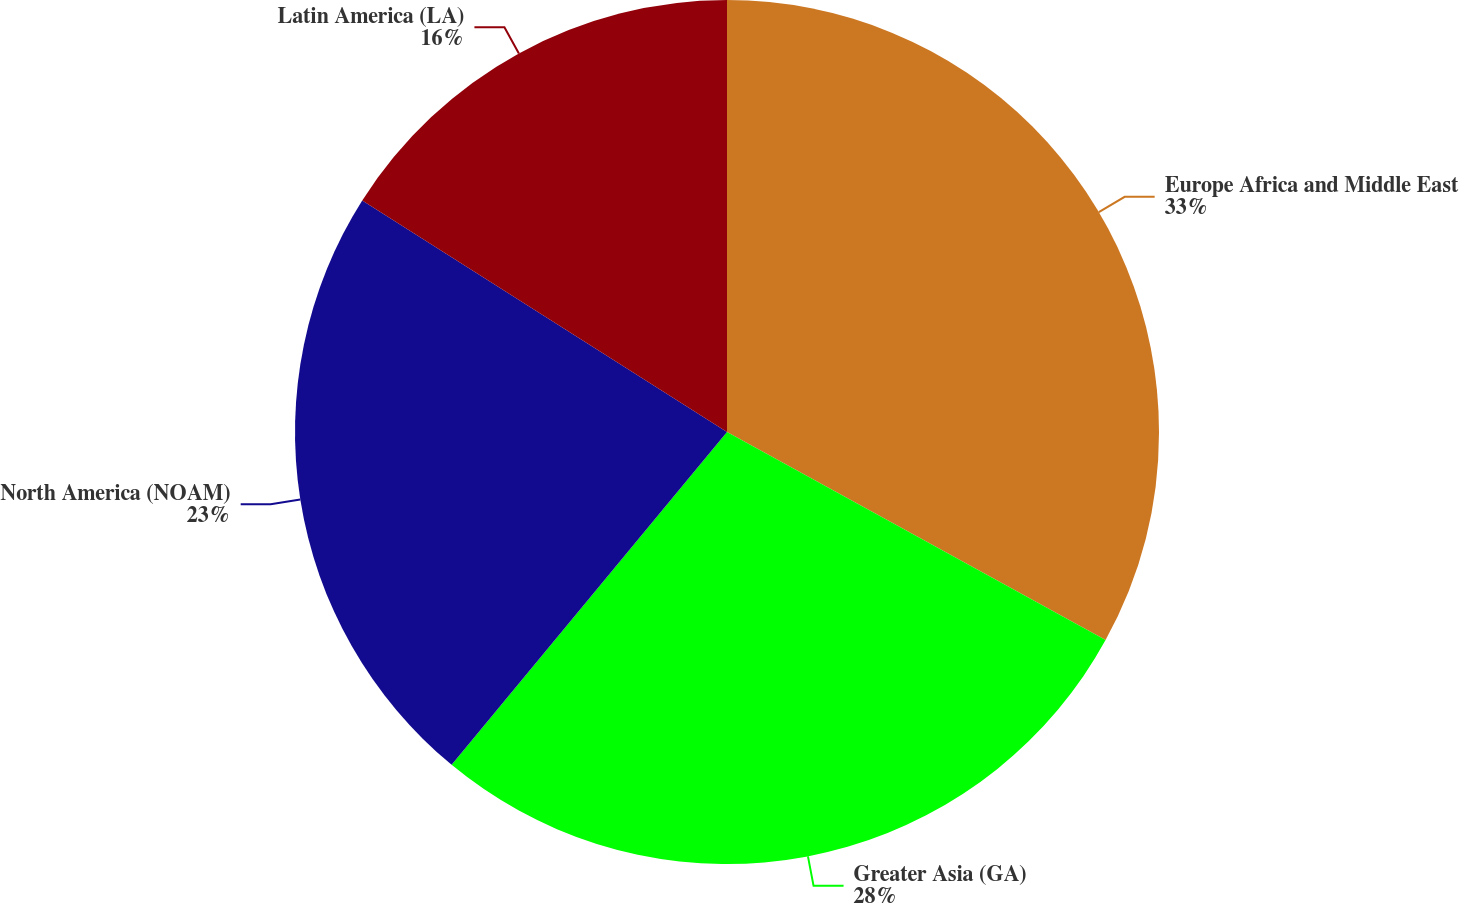Convert chart. <chart><loc_0><loc_0><loc_500><loc_500><pie_chart><fcel>Europe Africa and Middle East<fcel>Greater Asia (GA)<fcel>North America (NOAM)<fcel>Latin America (LA)<nl><fcel>33.0%<fcel>28.0%<fcel>23.0%<fcel>16.0%<nl></chart> 